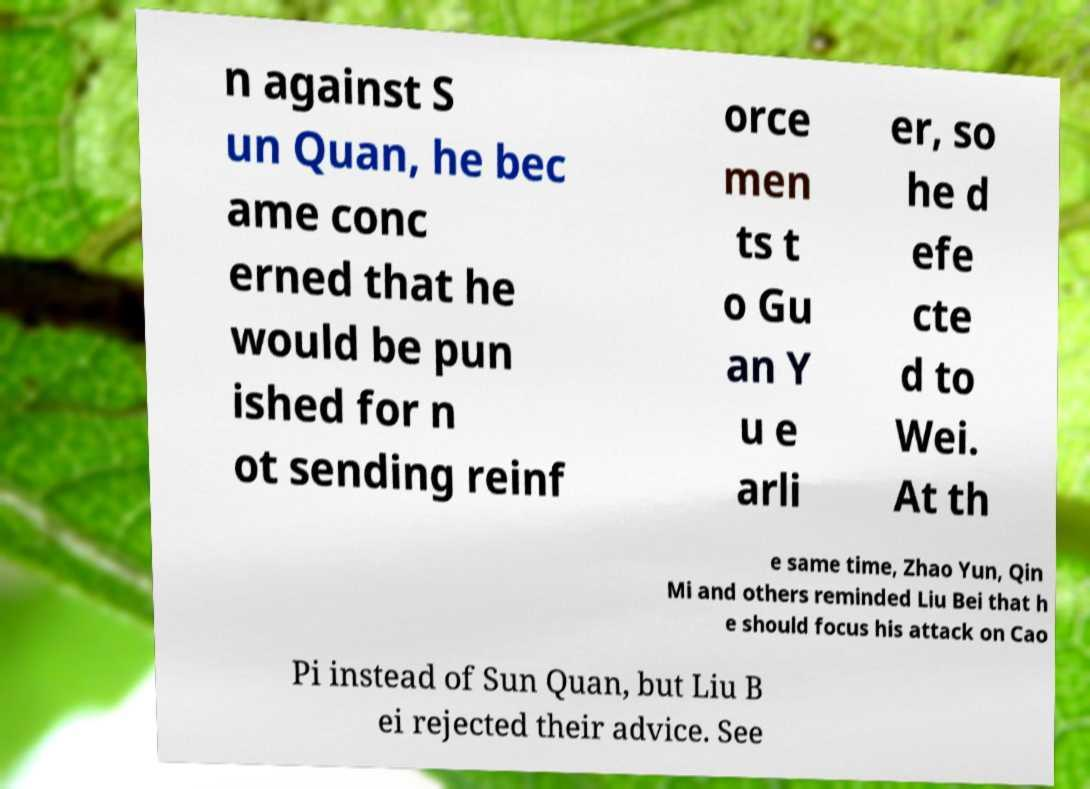For documentation purposes, I need the text within this image transcribed. Could you provide that? n against S un Quan, he bec ame conc erned that he would be pun ished for n ot sending reinf orce men ts t o Gu an Y u e arli er, so he d efe cte d to Wei. At th e same time, Zhao Yun, Qin Mi and others reminded Liu Bei that h e should focus his attack on Cao Pi instead of Sun Quan, but Liu B ei rejected their advice. See 